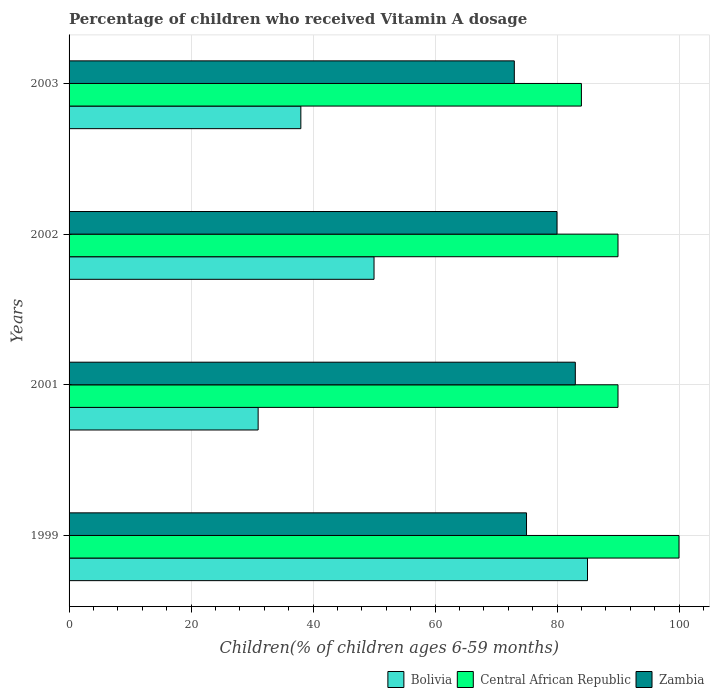How many different coloured bars are there?
Make the answer very short. 3. How many bars are there on the 4th tick from the top?
Ensure brevity in your answer.  3. Across all years, what is the maximum percentage of children who received Vitamin A dosage in Zambia?
Provide a short and direct response. 83. Across all years, what is the minimum percentage of children who received Vitamin A dosage in Bolivia?
Your answer should be compact. 31. What is the total percentage of children who received Vitamin A dosage in Zambia in the graph?
Make the answer very short. 311. What is the difference between the percentage of children who received Vitamin A dosage in Zambia in 2001 and the percentage of children who received Vitamin A dosage in Central African Republic in 2002?
Provide a succinct answer. -7. In the year 2002, what is the difference between the percentage of children who received Vitamin A dosage in Bolivia and percentage of children who received Vitamin A dosage in Central African Republic?
Offer a very short reply. -40. What is the ratio of the percentage of children who received Vitamin A dosage in Zambia in 2001 to that in 2003?
Your answer should be very brief. 1.14. Is the percentage of children who received Vitamin A dosage in Bolivia in 1999 less than that in 2002?
Offer a very short reply. No. Is the difference between the percentage of children who received Vitamin A dosage in Bolivia in 1999 and 2001 greater than the difference between the percentage of children who received Vitamin A dosage in Central African Republic in 1999 and 2001?
Offer a very short reply. Yes. What is the difference between the highest and the lowest percentage of children who received Vitamin A dosage in Central African Republic?
Ensure brevity in your answer.  16. What does the 2nd bar from the top in 1999 represents?
Provide a short and direct response. Central African Republic. What does the 2nd bar from the bottom in 1999 represents?
Make the answer very short. Central African Republic. How many bars are there?
Provide a succinct answer. 12. Are all the bars in the graph horizontal?
Provide a succinct answer. Yes. How many years are there in the graph?
Keep it short and to the point. 4. Are the values on the major ticks of X-axis written in scientific E-notation?
Ensure brevity in your answer.  No. Does the graph contain any zero values?
Your response must be concise. No. Does the graph contain grids?
Make the answer very short. Yes. Where does the legend appear in the graph?
Offer a terse response. Bottom right. What is the title of the graph?
Your response must be concise. Percentage of children who received Vitamin A dosage. Does "Greece" appear as one of the legend labels in the graph?
Your answer should be compact. No. What is the label or title of the X-axis?
Make the answer very short. Children(% of children ages 6-59 months). What is the label or title of the Y-axis?
Your response must be concise. Years. What is the Children(% of children ages 6-59 months) of Bolivia in 1999?
Your response must be concise. 85. What is the Children(% of children ages 6-59 months) in Zambia in 1999?
Give a very brief answer. 75. What is the Children(% of children ages 6-59 months) in Central African Republic in 2001?
Your response must be concise. 90. What is the Children(% of children ages 6-59 months) of Zambia in 2002?
Make the answer very short. 80. What is the Children(% of children ages 6-59 months) in Bolivia in 2003?
Keep it short and to the point. 38. What is the Children(% of children ages 6-59 months) in Zambia in 2003?
Offer a terse response. 73. Across all years, what is the maximum Children(% of children ages 6-59 months) of Central African Republic?
Provide a short and direct response. 100. Across all years, what is the maximum Children(% of children ages 6-59 months) in Zambia?
Offer a terse response. 83. Across all years, what is the minimum Children(% of children ages 6-59 months) in Bolivia?
Give a very brief answer. 31. What is the total Children(% of children ages 6-59 months) of Bolivia in the graph?
Offer a very short reply. 204. What is the total Children(% of children ages 6-59 months) of Central African Republic in the graph?
Offer a very short reply. 364. What is the total Children(% of children ages 6-59 months) of Zambia in the graph?
Make the answer very short. 311. What is the difference between the Children(% of children ages 6-59 months) of Bolivia in 1999 and that in 2001?
Your response must be concise. 54. What is the difference between the Children(% of children ages 6-59 months) in Central African Republic in 1999 and that in 2001?
Offer a very short reply. 10. What is the difference between the Children(% of children ages 6-59 months) in Zambia in 1999 and that in 2001?
Your answer should be very brief. -8. What is the difference between the Children(% of children ages 6-59 months) in Bolivia in 1999 and that in 2002?
Offer a terse response. 35. What is the difference between the Children(% of children ages 6-59 months) in Zambia in 1999 and that in 2002?
Give a very brief answer. -5. What is the difference between the Children(% of children ages 6-59 months) of Central African Republic in 1999 and that in 2003?
Your answer should be compact. 16. What is the difference between the Children(% of children ages 6-59 months) of Zambia in 1999 and that in 2003?
Your answer should be compact. 2. What is the difference between the Children(% of children ages 6-59 months) of Central African Republic in 2001 and that in 2002?
Ensure brevity in your answer.  0. What is the difference between the Children(% of children ages 6-59 months) in Bolivia in 1999 and the Children(% of children ages 6-59 months) in Central African Republic in 2002?
Offer a very short reply. -5. What is the difference between the Children(% of children ages 6-59 months) of Bolivia in 1999 and the Children(% of children ages 6-59 months) of Zambia in 2003?
Provide a succinct answer. 12. What is the difference between the Children(% of children ages 6-59 months) in Central African Republic in 1999 and the Children(% of children ages 6-59 months) in Zambia in 2003?
Offer a very short reply. 27. What is the difference between the Children(% of children ages 6-59 months) in Bolivia in 2001 and the Children(% of children ages 6-59 months) in Central African Republic in 2002?
Give a very brief answer. -59. What is the difference between the Children(% of children ages 6-59 months) of Bolivia in 2001 and the Children(% of children ages 6-59 months) of Zambia in 2002?
Provide a succinct answer. -49. What is the difference between the Children(% of children ages 6-59 months) of Bolivia in 2001 and the Children(% of children ages 6-59 months) of Central African Republic in 2003?
Provide a succinct answer. -53. What is the difference between the Children(% of children ages 6-59 months) of Bolivia in 2001 and the Children(% of children ages 6-59 months) of Zambia in 2003?
Give a very brief answer. -42. What is the difference between the Children(% of children ages 6-59 months) in Bolivia in 2002 and the Children(% of children ages 6-59 months) in Central African Republic in 2003?
Give a very brief answer. -34. What is the difference between the Children(% of children ages 6-59 months) in Bolivia in 2002 and the Children(% of children ages 6-59 months) in Zambia in 2003?
Provide a short and direct response. -23. What is the difference between the Children(% of children ages 6-59 months) of Central African Republic in 2002 and the Children(% of children ages 6-59 months) of Zambia in 2003?
Ensure brevity in your answer.  17. What is the average Children(% of children ages 6-59 months) of Central African Republic per year?
Make the answer very short. 91. What is the average Children(% of children ages 6-59 months) in Zambia per year?
Your answer should be compact. 77.75. In the year 1999, what is the difference between the Children(% of children ages 6-59 months) in Bolivia and Children(% of children ages 6-59 months) in Zambia?
Your response must be concise. 10. In the year 1999, what is the difference between the Children(% of children ages 6-59 months) of Central African Republic and Children(% of children ages 6-59 months) of Zambia?
Provide a succinct answer. 25. In the year 2001, what is the difference between the Children(% of children ages 6-59 months) of Bolivia and Children(% of children ages 6-59 months) of Central African Republic?
Provide a short and direct response. -59. In the year 2001, what is the difference between the Children(% of children ages 6-59 months) in Bolivia and Children(% of children ages 6-59 months) in Zambia?
Offer a very short reply. -52. In the year 2001, what is the difference between the Children(% of children ages 6-59 months) of Central African Republic and Children(% of children ages 6-59 months) of Zambia?
Provide a short and direct response. 7. In the year 2002, what is the difference between the Children(% of children ages 6-59 months) of Bolivia and Children(% of children ages 6-59 months) of Zambia?
Offer a very short reply. -30. In the year 2003, what is the difference between the Children(% of children ages 6-59 months) of Bolivia and Children(% of children ages 6-59 months) of Central African Republic?
Your answer should be compact. -46. In the year 2003, what is the difference between the Children(% of children ages 6-59 months) of Bolivia and Children(% of children ages 6-59 months) of Zambia?
Your response must be concise. -35. In the year 2003, what is the difference between the Children(% of children ages 6-59 months) in Central African Republic and Children(% of children ages 6-59 months) in Zambia?
Provide a short and direct response. 11. What is the ratio of the Children(% of children ages 6-59 months) of Bolivia in 1999 to that in 2001?
Your answer should be very brief. 2.74. What is the ratio of the Children(% of children ages 6-59 months) of Zambia in 1999 to that in 2001?
Your answer should be very brief. 0.9. What is the ratio of the Children(% of children ages 6-59 months) in Central African Republic in 1999 to that in 2002?
Offer a terse response. 1.11. What is the ratio of the Children(% of children ages 6-59 months) in Bolivia in 1999 to that in 2003?
Ensure brevity in your answer.  2.24. What is the ratio of the Children(% of children ages 6-59 months) of Central African Republic in 1999 to that in 2003?
Your answer should be compact. 1.19. What is the ratio of the Children(% of children ages 6-59 months) of Zambia in 1999 to that in 2003?
Ensure brevity in your answer.  1.03. What is the ratio of the Children(% of children ages 6-59 months) in Bolivia in 2001 to that in 2002?
Provide a short and direct response. 0.62. What is the ratio of the Children(% of children ages 6-59 months) in Central African Republic in 2001 to that in 2002?
Keep it short and to the point. 1. What is the ratio of the Children(% of children ages 6-59 months) in Zambia in 2001 to that in 2002?
Offer a very short reply. 1.04. What is the ratio of the Children(% of children ages 6-59 months) of Bolivia in 2001 to that in 2003?
Your answer should be very brief. 0.82. What is the ratio of the Children(% of children ages 6-59 months) in Central African Republic in 2001 to that in 2003?
Offer a terse response. 1.07. What is the ratio of the Children(% of children ages 6-59 months) in Zambia in 2001 to that in 2003?
Provide a succinct answer. 1.14. What is the ratio of the Children(% of children ages 6-59 months) in Bolivia in 2002 to that in 2003?
Offer a terse response. 1.32. What is the ratio of the Children(% of children ages 6-59 months) in Central African Republic in 2002 to that in 2003?
Give a very brief answer. 1.07. What is the ratio of the Children(% of children ages 6-59 months) of Zambia in 2002 to that in 2003?
Keep it short and to the point. 1.1. What is the difference between the highest and the second highest Children(% of children ages 6-59 months) of Bolivia?
Provide a short and direct response. 35. What is the difference between the highest and the lowest Children(% of children ages 6-59 months) of Bolivia?
Your answer should be very brief. 54. 